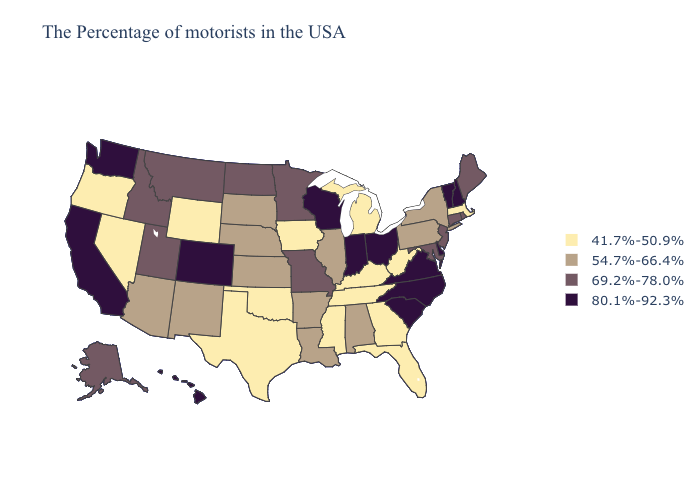Does South Dakota have a lower value than Arkansas?
Quick response, please. No. What is the value of Tennessee?
Answer briefly. 41.7%-50.9%. Does Maine have the highest value in the Northeast?
Short answer required. No. Name the states that have a value in the range 80.1%-92.3%?
Keep it brief. New Hampshire, Vermont, Delaware, Virginia, North Carolina, South Carolina, Ohio, Indiana, Wisconsin, Colorado, California, Washington, Hawaii. Name the states that have a value in the range 80.1%-92.3%?
Concise answer only. New Hampshire, Vermont, Delaware, Virginia, North Carolina, South Carolina, Ohio, Indiana, Wisconsin, Colorado, California, Washington, Hawaii. Among the states that border Ohio , does Kentucky have the lowest value?
Give a very brief answer. Yes. Which states have the lowest value in the USA?
Quick response, please. Massachusetts, West Virginia, Florida, Georgia, Michigan, Kentucky, Tennessee, Mississippi, Iowa, Oklahoma, Texas, Wyoming, Nevada, Oregon. Which states hav the highest value in the MidWest?
Write a very short answer. Ohio, Indiana, Wisconsin. Name the states that have a value in the range 54.7%-66.4%?
Quick response, please. New York, Pennsylvania, Alabama, Illinois, Louisiana, Arkansas, Kansas, Nebraska, South Dakota, New Mexico, Arizona. What is the lowest value in states that border South Carolina?
Keep it brief. 41.7%-50.9%. Name the states that have a value in the range 80.1%-92.3%?
Keep it brief. New Hampshire, Vermont, Delaware, Virginia, North Carolina, South Carolina, Ohio, Indiana, Wisconsin, Colorado, California, Washington, Hawaii. What is the value of Pennsylvania?
Keep it brief. 54.7%-66.4%. Name the states that have a value in the range 69.2%-78.0%?
Quick response, please. Maine, Rhode Island, Connecticut, New Jersey, Maryland, Missouri, Minnesota, North Dakota, Utah, Montana, Idaho, Alaska. Name the states that have a value in the range 41.7%-50.9%?
Quick response, please. Massachusetts, West Virginia, Florida, Georgia, Michigan, Kentucky, Tennessee, Mississippi, Iowa, Oklahoma, Texas, Wyoming, Nevada, Oregon. Name the states that have a value in the range 80.1%-92.3%?
Keep it brief. New Hampshire, Vermont, Delaware, Virginia, North Carolina, South Carolina, Ohio, Indiana, Wisconsin, Colorado, California, Washington, Hawaii. 